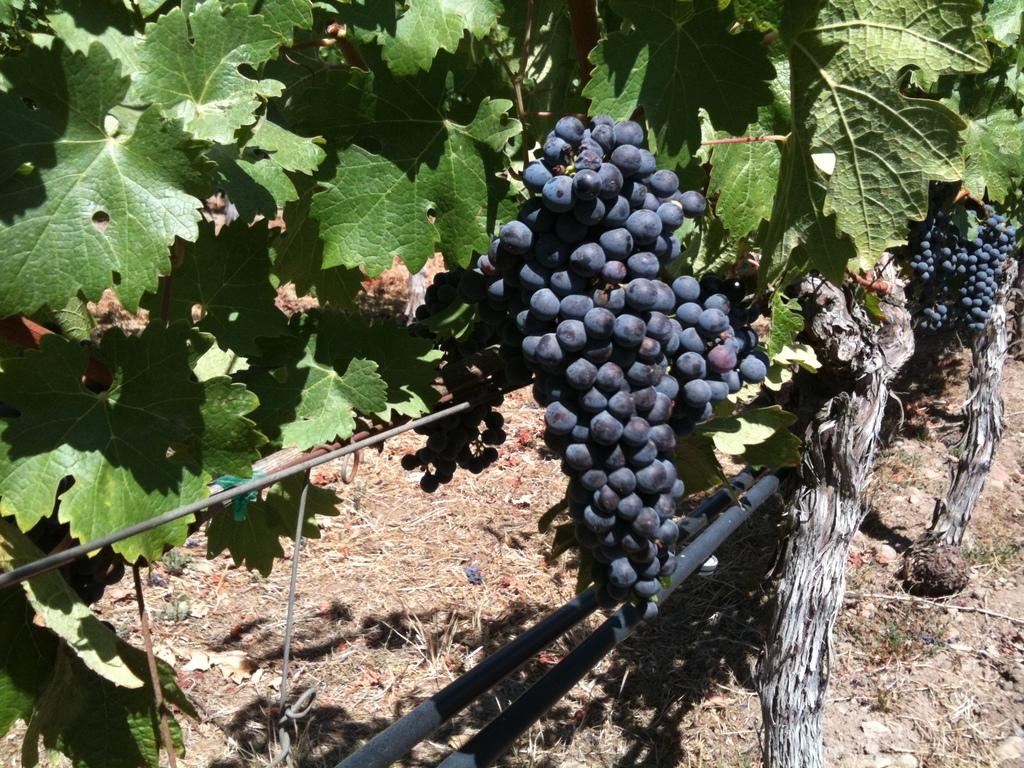What type of fruit is present in the image? There are grapes in the image. What type of vegetation can be seen in the image? There are trees in the image. What type of chair is depicted in the image? There is no chair present in the image. Is there a jail visible in the image? There is no jail present in the image. 